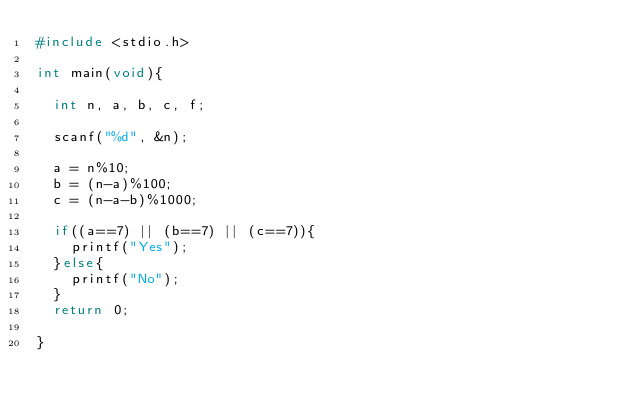<code> <loc_0><loc_0><loc_500><loc_500><_C_>#include <stdio.h>

int main(void){
  
  int n, a, b, c, f;
  
  scanf("%d", &n);
  
  a = n%10;
  b = (n-a)%100;
  c = (n-a-b)%1000;
  
  if((a==7) || (b==7) || (c==7)){
    printf("Yes");
  }else{
    printf("No");
  }
  return 0;

}</code> 